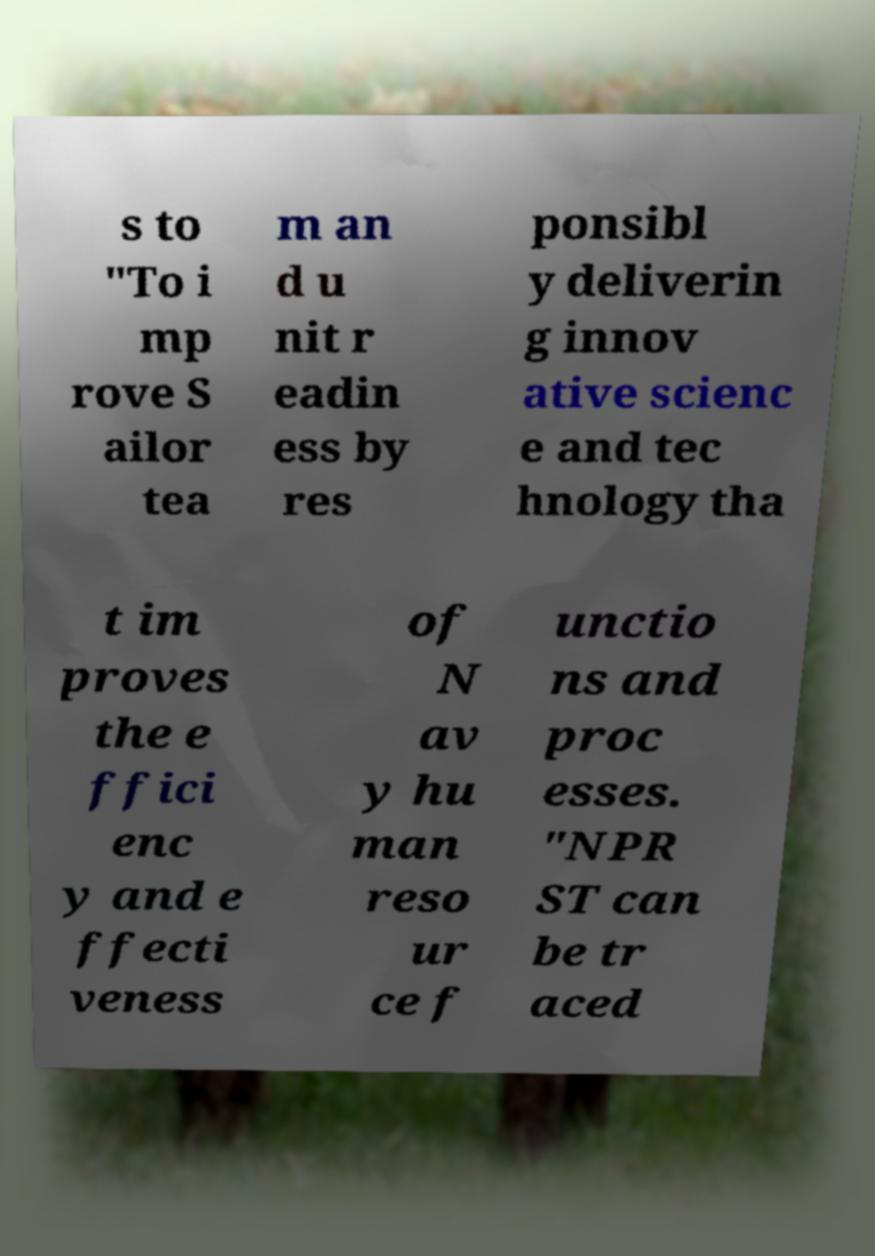For documentation purposes, I need the text within this image transcribed. Could you provide that? s to "To i mp rove S ailor tea m an d u nit r eadin ess by res ponsibl y deliverin g innov ative scienc e and tec hnology tha t im proves the e ffici enc y and e ffecti veness of N av y hu man reso ur ce f unctio ns and proc esses. "NPR ST can be tr aced 